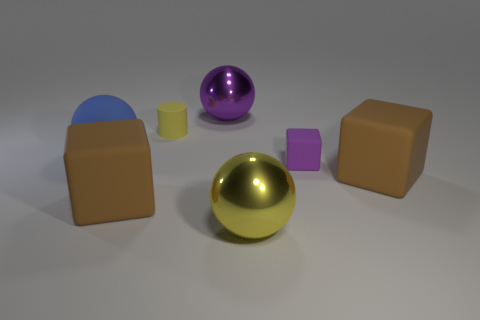Subtract all large matte cubes. How many cubes are left? 1 Add 1 big green cubes. How many objects exist? 8 Subtract 1 spheres. How many spheres are left? 2 Subtract all cylinders. How many objects are left? 6 Add 4 big purple spheres. How many big purple spheres are left? 5 Add 3 cubes. How many cubes exist? 6 Subtract 0 cyan spheres. How many objects are left? 7 Subtract all rubber objects. Subtract all yellow spheres. How many objects are left? 1 